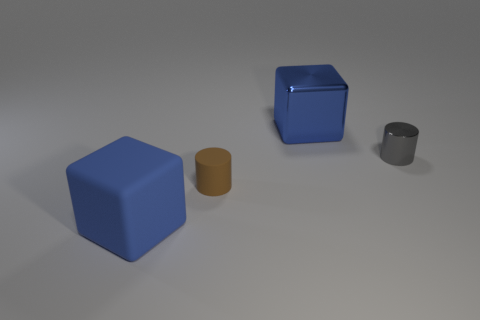Is the number of gray shiny things on the right side of the tiny gray cylinder less than the number of brown rubber objects that are behind the large blue metallic cube?
Ensure brevity in your answer.  No. There is a big block that is in front of the small brown cylinder; is its color the same as the big thing that is to the right of the small brown rubber cylinder?
Offer a very short reply. Yes. Is there a big thing that has the same material as the small brown cylinder?
Offer a terse response. Yes. What is the size of the blue thing that is on the right side of the blue object that is in front of the small gray metal cylinder?
Ensure brevity in your answer.  Large. Is the number of large red rubber cylinders greater than the number of big rubber blocks?
Offer a very short reply. No. Do the blue thing to the right of the brown rubber cylinder and the big matte cube have the same size?
Make the answer very short. Yes. How many other objects are the same color as the big rubber thing?
Ensure brevity in your answer.  1. Does the gray metallic thing have the same shape as the big blue rubber thing?
Provide a succinct answer. No. There is a gray metal thing that is the same shape as the small brown object; what is its size?
Offer a terse response. Small. Is the number of blue cubes behind the tiny brown thing greater than the number of blue rubber objects right of the gray cylinder?
Your answer should be compact. Yes. 